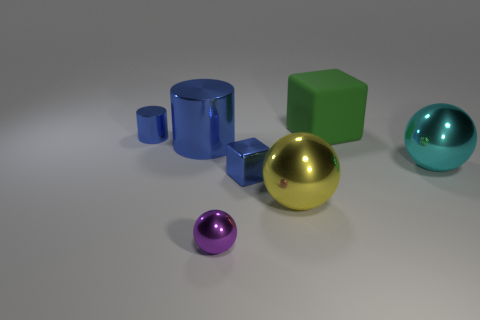Add 3 large green things. How many objects exist? 10 Subtract all big yellow balls. How many balls are left? 2 Subtract all purple balls. How many balls are left? 2 Subtract 1 spheres. How many spheres are left? 2 Subtract all big yellow cylinders. Subtract all blue cylinders. How many objects are left? 5 Add 1 large cyan spheres. How many large cyan spheres are left? 2 Add 3 red matte cubes. How many red matte cubes exist? 3 Subtract 0 gray blocks. How many objects are left? 7 Subtract all balls. How many objects are left? 4 Subtract all yellow spheres. Subtract all green cylinders. How many spheres are left? 2 